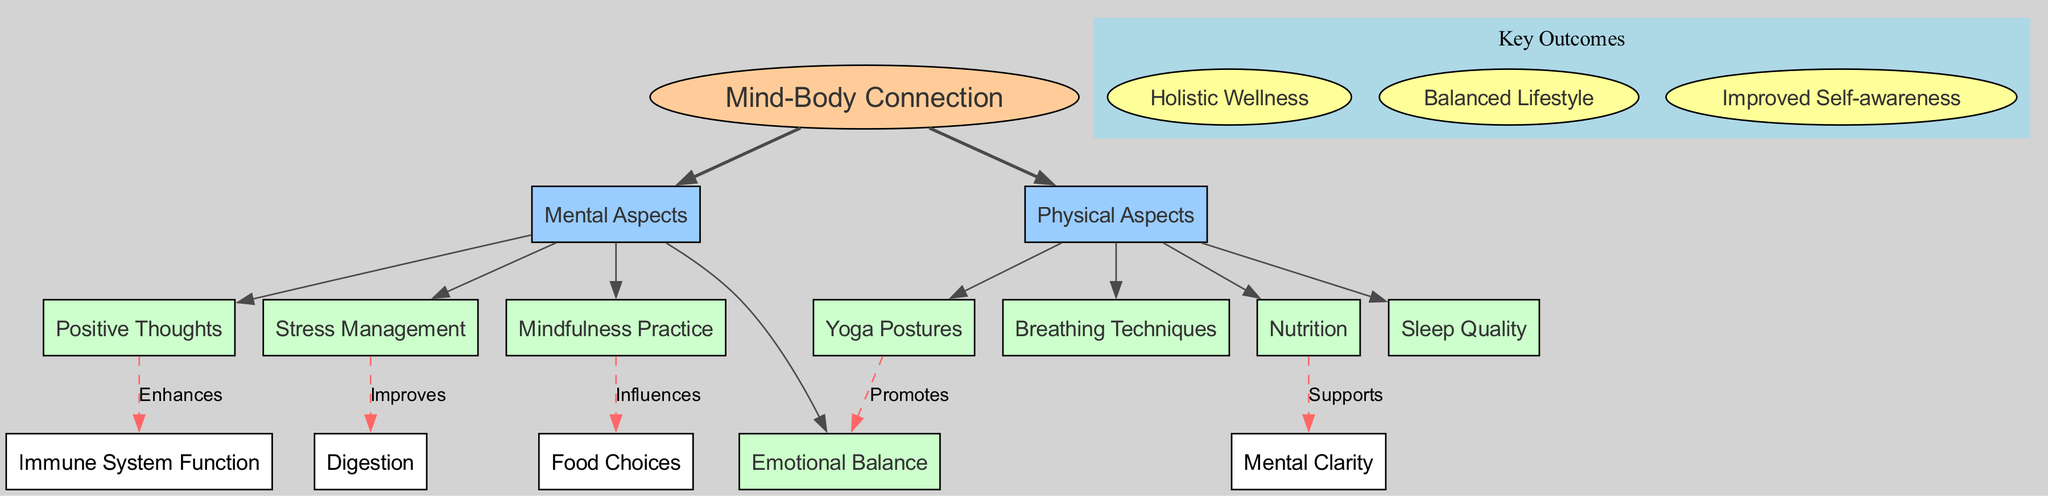What's the central concept of the diagram? The central concept is clearly labeled in the diagram and is indicated within an ellipse. It is the primary theme around which all other elements are organized.
Answer: Mind-Body Connection How many main branches are there? By counting the main branches connected to the central concept, we identify that there are two distinct categories visible in the diagram, each representing a different aspect of the mind-body connection.
Answer: 2 Which mental aspect influences food choices? Examining the connection arrows, we can see that one of the mental aspects named 'Mindfulness Practice' has a specific dashed connection leading to 'Food Choices', indicating its influence on that area.
Answer: Mindfulness Practice What does yoga postures promote? The relationship noted in the diagram indicates that 'Yoga Postures' has a direct influence on a specific aspect of mental wellbeing, labeled as 'Emotional Balance'. This connection highlights the role of yoga in promoting emotional health.
Answer: Emotional Balance Which physical aspect supports mental clarity? By reviewing the connection arrows, we find that 'Nutrition' has an explicit relationship indicating the support it offers to 'Mental Clarity’. This suggests a clear benefit of nutrition for cognitive processes.
Answer: Nutrition How many key outcomes are there? The diagram has a specific section labeled 'Key Outcomes', where each outcome is listed. Counting the individual outcomes provides a clear total.
Answer: 3 What is the relationship indicated between stress management and digestion? The diagram illustrates the relationship with a dashed arrow labeled 'Improves', showing a direct impact of 'Stress Management' on 'Digestion.' This suggests that managing stress positively affects digestive health.
Answer: Improves What promotes emotional balance? There's a direct connection illustrated in the diagram where 'Yoga Postures' is linked to 'Emotional Balance', emphasizing that practicing yoga assists in achieving a balanced emotional state.
Answer: Yoga Postures What does positive thoughts enhance? Looking at the connection arrows, we find that 'Positive Thoughts' specifically enhances 'Immune System Function', indicating the beneficial effects of a positive mindset on physical health.
Answer: Immune System Function 